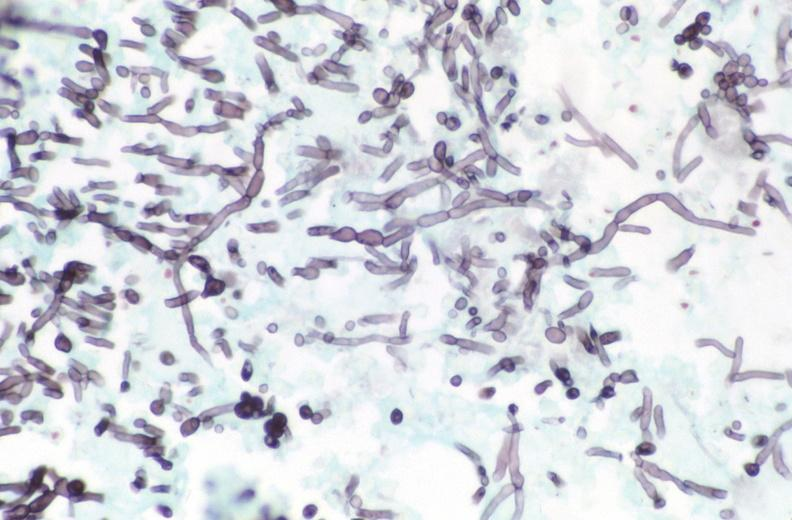s gastrointestinal present?
Answer the question using a single word or phrase. Yes 